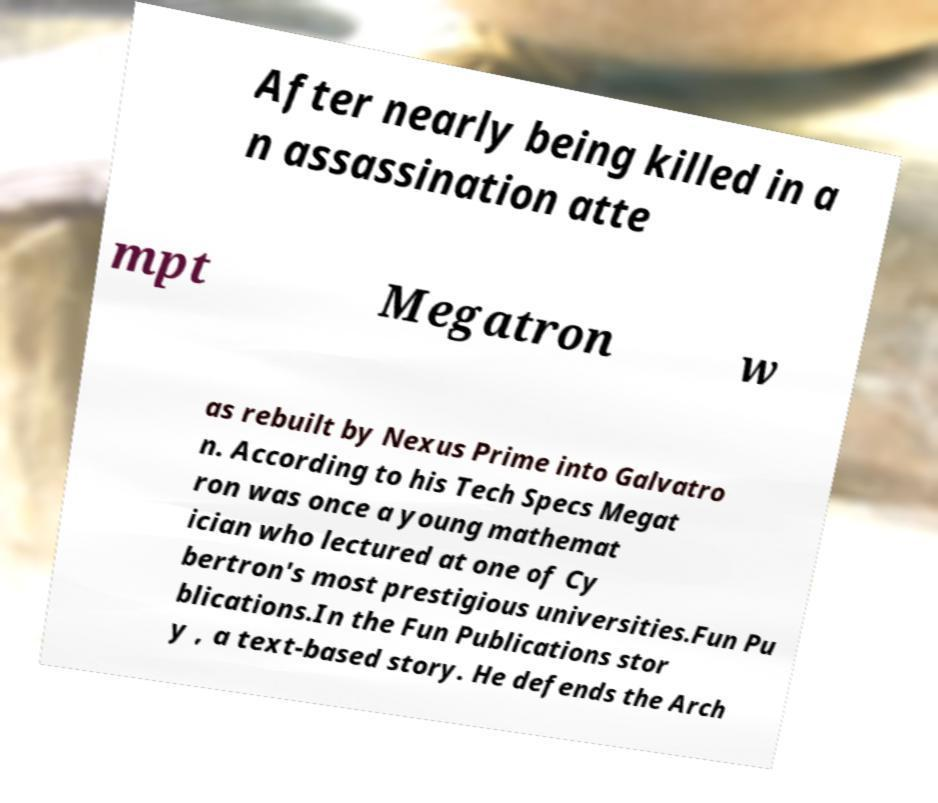Could you extract and type out the text from this image? After nearly being killed in a n assassination atte mpt Megatron w as rebuilt by Nexus Prime into Galvatro n. According to his Tech Specs Megat ron was once a young mathemat ician who lectured at one of Cy bertron's most prestigious universities.Fun Pu blications.In the Fun Publications stor y , a text-based story. He defends the Arch 